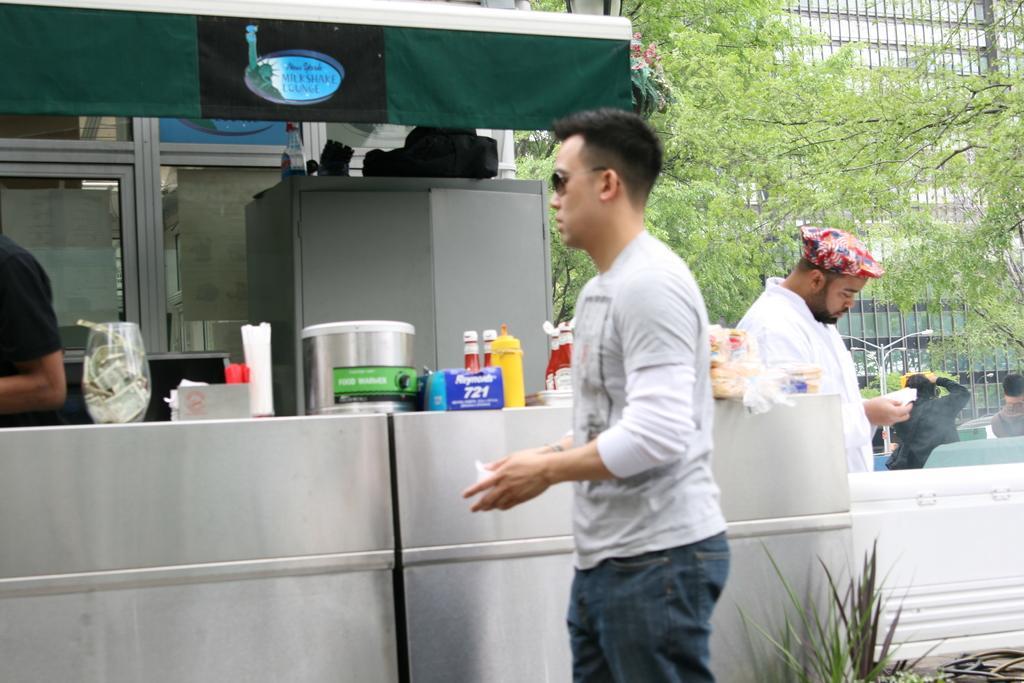Can you describe this image briefly? A man is standing and holding an object in his hands and there are bottles,food items,tin,tissue papers and other objects on a platform and there is a cupboard,glass doors and a tent. There are two persons standing. In the background on the right side there are trees,light poles,building,glass doors,few persons,boxes and a plant. 